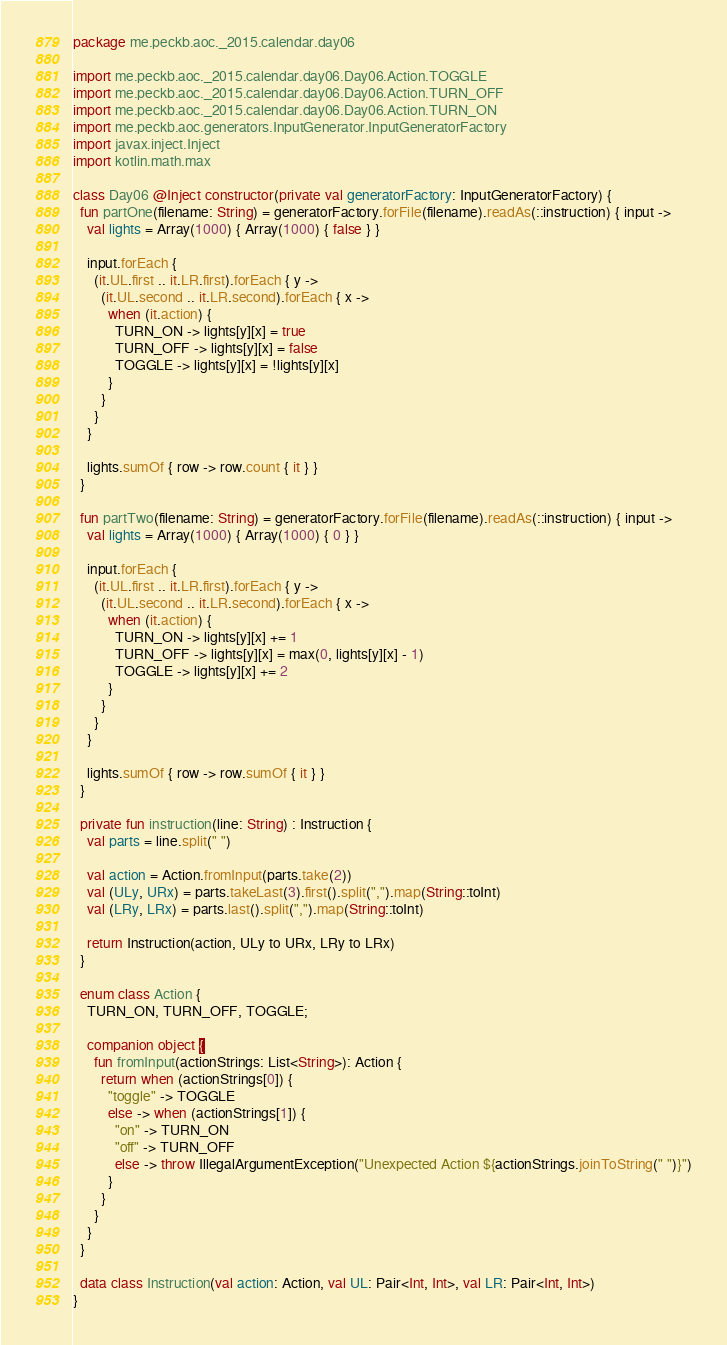Convert code to text. <code><loc_0><loc_0><loc_500><loc_500><_Kotlin_>package me.peckb.aoc._2015.calendar.day06

import me.peckb.aoc._2015.calendar.day06.Day06.Action.TOGGLE
import me.peckb.aoc._2015.calendar.day06.Day06.Action.TURN_OFF
import me.peckb.aoc._2015.calendar.day06.Day06.Action.TURN_ON
import me.peckb.aoc.generators.InputGenerator.InputGeneratorFactory
import javax.inject.Inject
import kotlin.math.max

class Day06 @Inject constructor(private val generatorFactory: InputGeneratorFactory) {
  fun partOne(filename: String) = generatorFactory.forFile(filename).readAs(::instruction) { input ->
    val lights = Array(1000) { Array(1000) { false } }

    input.forEach {
      (it.UL.first .. it.LR.first).forEach { y ->
        (it.UL.second .. it.LR.second).forEach { x ->
          when (it.action) {
            TURN_ON -> lights[y][x] = true
            TURN_OFF -> lights[y][x] = false
            TOGGLE -> lights[y][x] = !lights[y][x]
          }
        }
      }
    }

    lights.sumOf { row -> row.count { it } }
  }

  fun partTwo(filename: String) = generatorFactory.forFile(filename).readAs(::instruction) { input ->
    val lights = Array(1000) { Array(1000) { 0 } }

    input.forEach {
      (it.UL.first .. it.LR.first).forEach { y ->
        (it.UL.second .. it.LR.second).forEach { x ->
          when (it.action) {
            TURN_ON -> lights[y][x] += 1
            TURN_OFF -> lights[y][x] = max(0, lights[y][x] - 1)
            TOGGLE -> lights[y][x] += 2
          }
        }
      }
    }

    lights.sumOf { row -> row.sumOf { it } }
  }

  private fun instruction(line: String) : Instruction {
    val parts = line.split(" ")

    val action = Action.fromInput(parts.take(2))
    val (ULy, URx) = parts.takeLast(3).first().split(",").map(String::toInt)
    val (LRy, LRx) = parts.last().split(",").map(String::toInt)

    return Instruction(action, ULy to URx, LRy to LRx)
  }

  enum class Action {
    TURN_ON, TURN_OFF, TOGGLE;

    companion object {
      fun fromInput(actionStrings: List<String>): Action {
        return when (actionStrings[0]) {
          "toggle" -> TOGGLE
          else -> when (actionStrings[1]) {
            "on" -> TURN_ON
            "off" -> TURN_OFF
            else -> throw IllegalArgumentException("Unexpected Action ${actionStrings.joinToString(" ")}")
          }
        }
      }
    }
  }

  data class Instruction(val action: Action, val UL: Pair<Int, Int>, val LR: Pair<Int, Int>)
}
</code> 